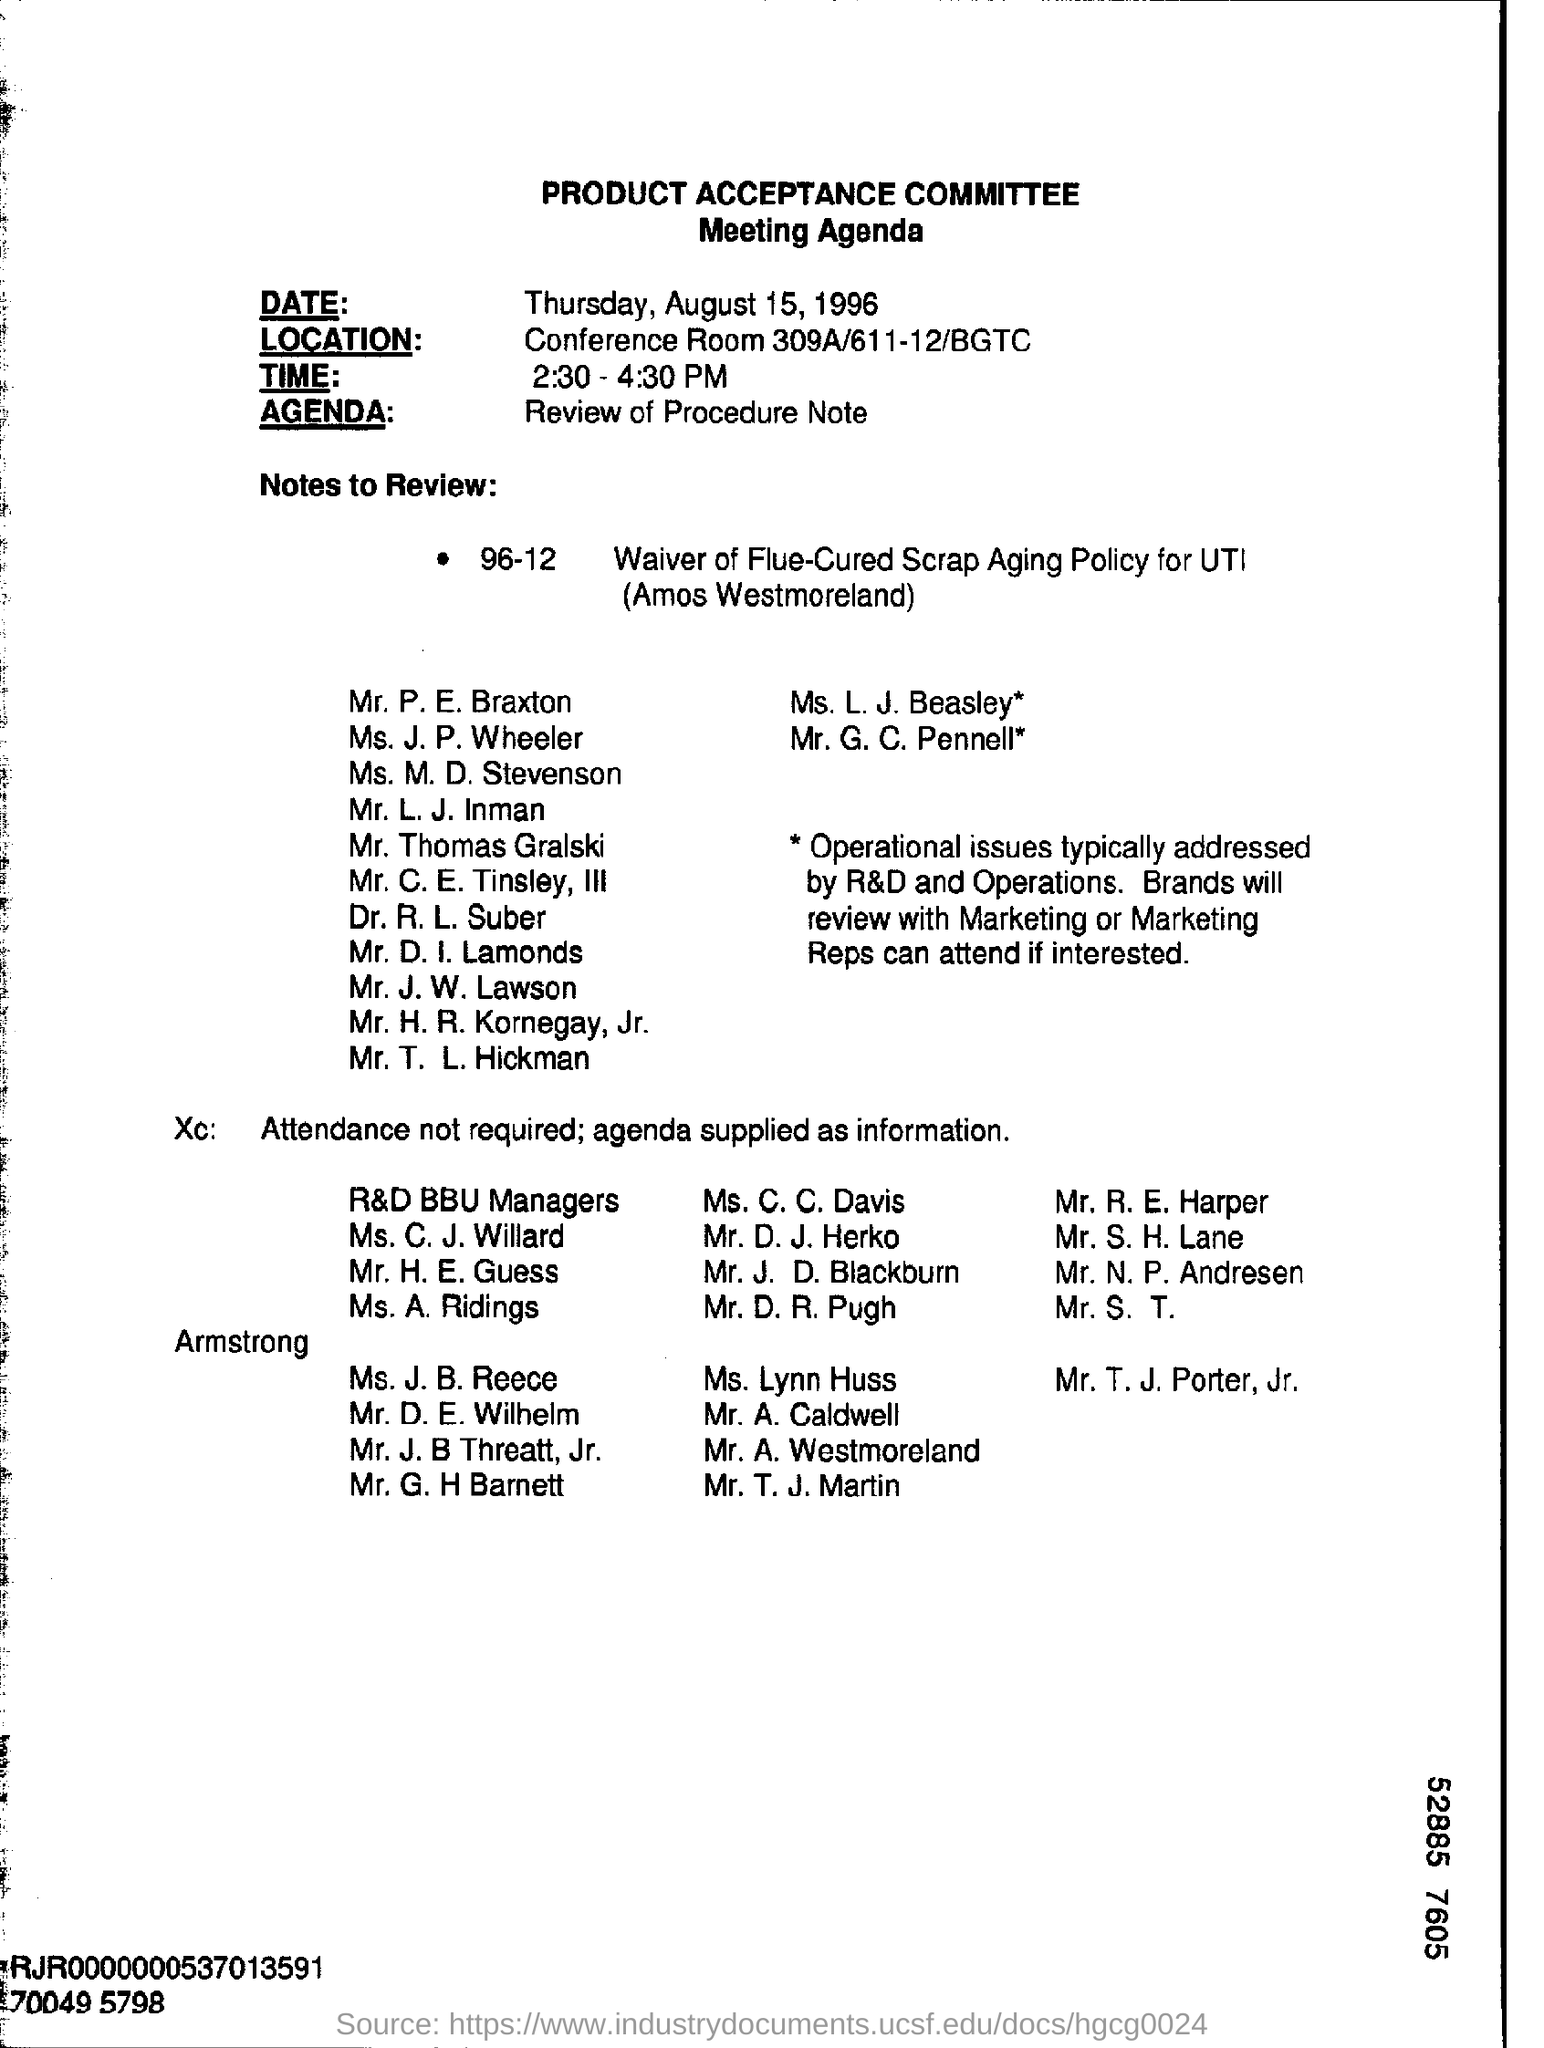Give some essential details in this illustration. The location of the meeting is in Conference Room 309A/611-12/BGTC. The Product Acceptance Committee is the name of the committee. The agenda of the meeting is to review the procedure note. 